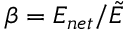Convert formula to latex. <formula><loc_0><loc_0><loc_500><loc_500>\beta = E _ { n e t } / \tilde { E }</formula> 